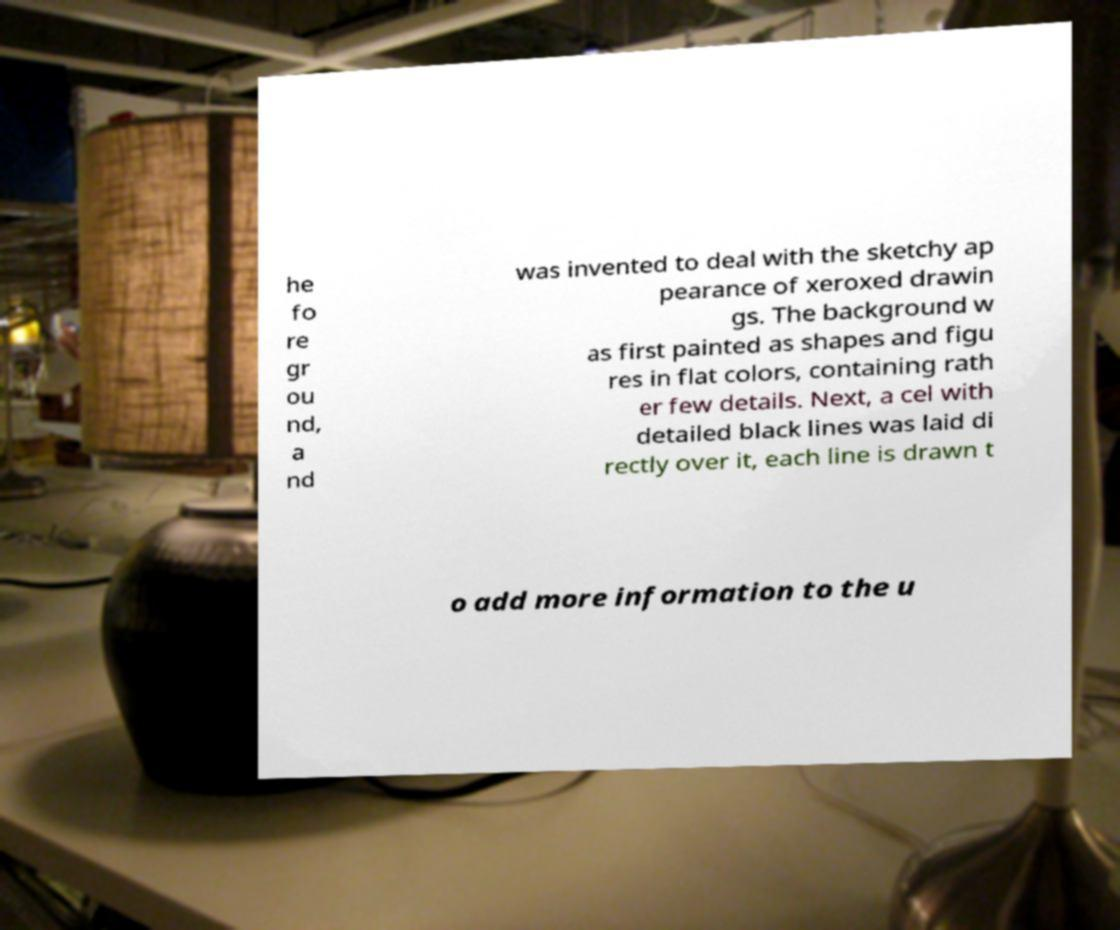Could you assist in decoding the text presented in this image and type it out clearly? he fo re gr ou nd, a nd was invented to deal with the sketchy ap pearance of xeroxed drawin gs. The background w as first painted as shapes and figu res in flat colors, containing rath er few details. Next, a cel with detailed black lines was laid di rectly over it, each line is drawn t o add more information to the u 